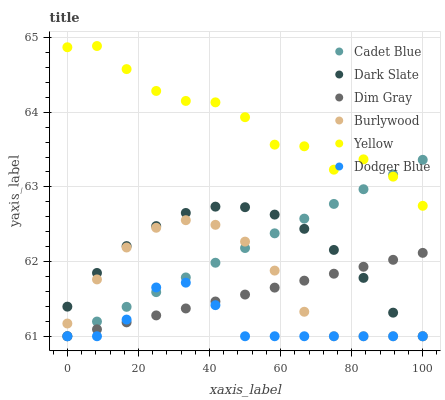Does Dodger Blue have the minimum area under the curve?
Answer yes or no. Yes. Does Yellow have the maximum area under the curve?
Answer yes or no. Yes. Does Burlywood have the minimum area under the curve?
Answer yes or no. No. Does Burlywood have the maximum area under the curve?
Answer yes or no. No. Is Dim Gray the smoothest?
Answer yes or no. Yes. Is Yellow the roughest?
Answer yes or no. Yes. Is Burlywood the smoothest?
Answer yes or no. No. Is Burlywood the roughest?
Answer yes or no. No. Does Dim Gray have the lowest value?
Answer yes or no. Yes. Does Yellow have the lowest value?
Answer yes or no. No. Does Yellow have the highest value?
Answer yes or no. Yes. Does Burlywood have the highest value?
Answer yes or no. No. Is Dark Slate less than Yellow?
Answer yes or no. Yes. Is Yellow greater than Burlywood?
Answer yes or no. Yes. Does Dim Gray intersect Cadet Blue?
Answer yes or no. Yes. Is Dim Gray less than Cadet Blue?
Answer yes or no. No. Is Dim Gray greater than Cadet Blue?
Answer yes or no. No. Does Dark Slate intersect Yellow?
Answer yes or no. No. 